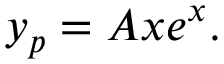Convert formula to latex. <formula><loc_0><loc_0><loc_500><loc_500>y _ { p } = A x e ^ { x } .</formula> 